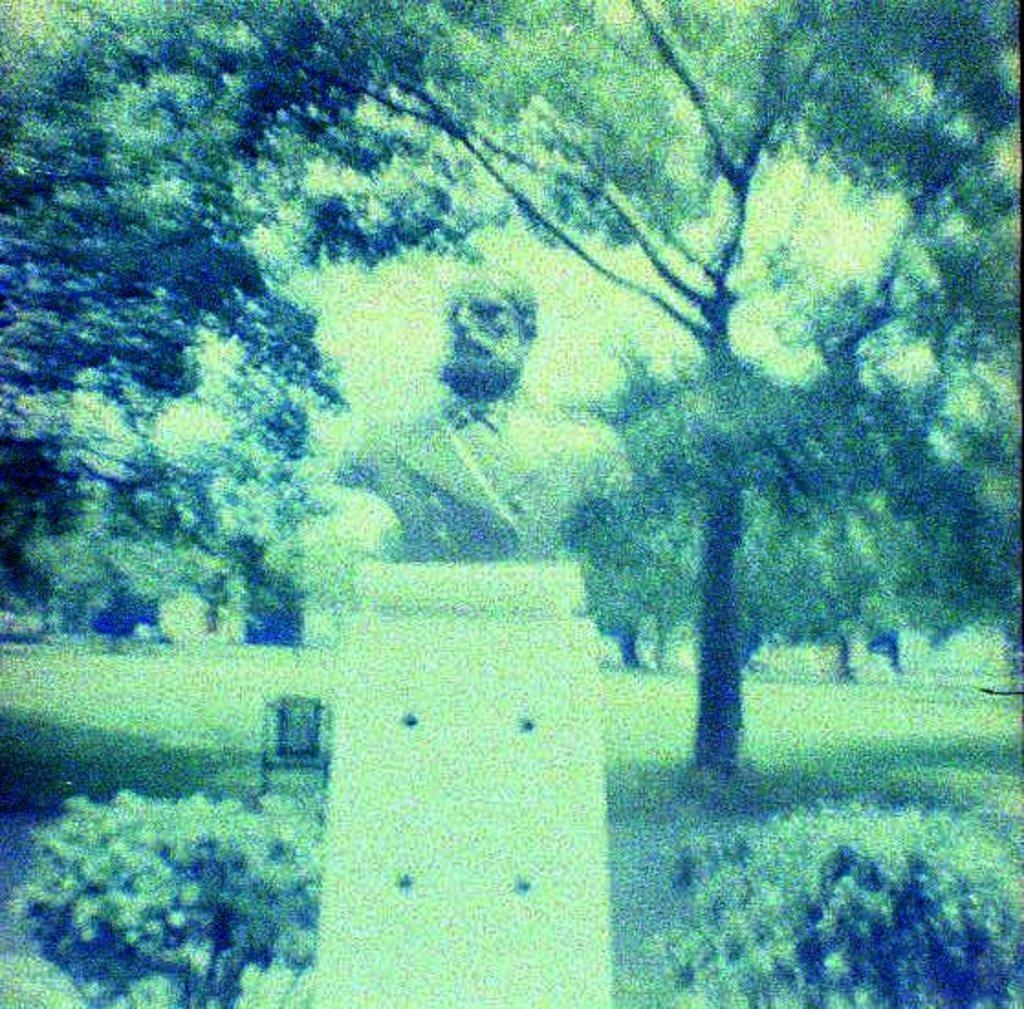What is the main subject of the image? There is a statue in the image. How is the statue positioned in the image? The statue is on a pedestal. What type of natural elements can be seen in the image? There are trees and plants visible in the image. What part of the natural environment is visible in the image? The sky and the ground are visible in the image. Are there any man-made objects in the image besides the statue? Yes, there is a chair in the image. What type of cord is being used to control the statue's movements in the image? There is no cord present in the image, and the statue is not depicted as moving. What wish does the statue grant to those who visit it in the image? The image does not provide any information about the statue granting wishes. 